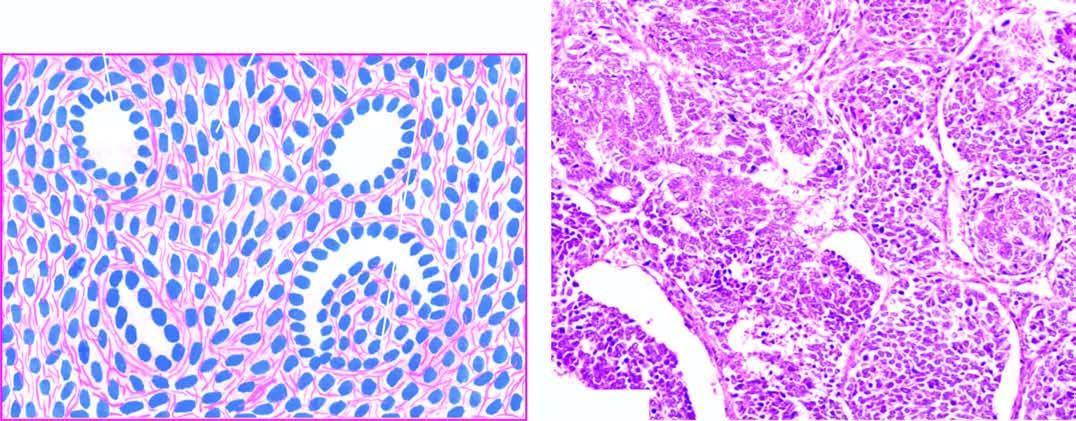s infarcted area predominance of small round to spindled sarcomatoid tumour cells?
Answer the question using a single word or phrase. No 